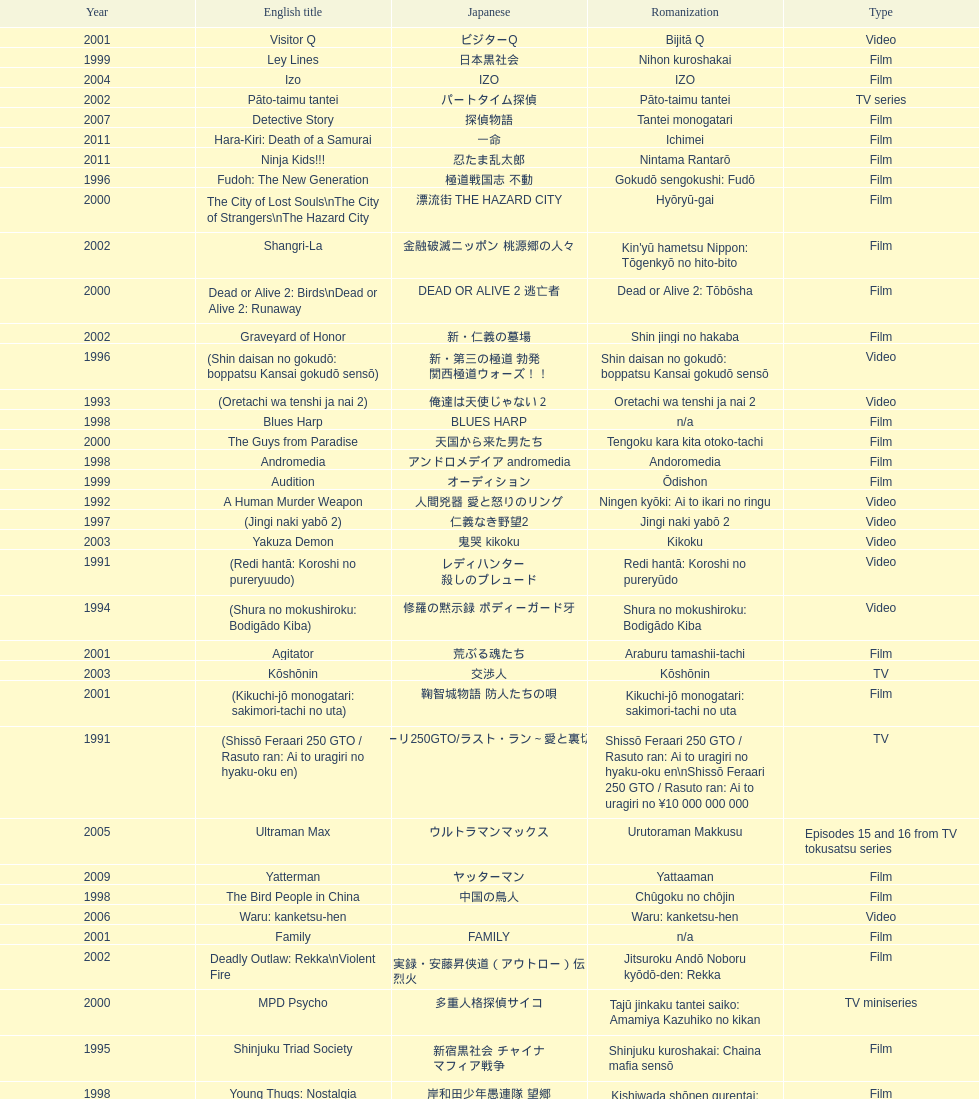Which title is listed next after "the way to fight"? Fudoh: The New Generation. 